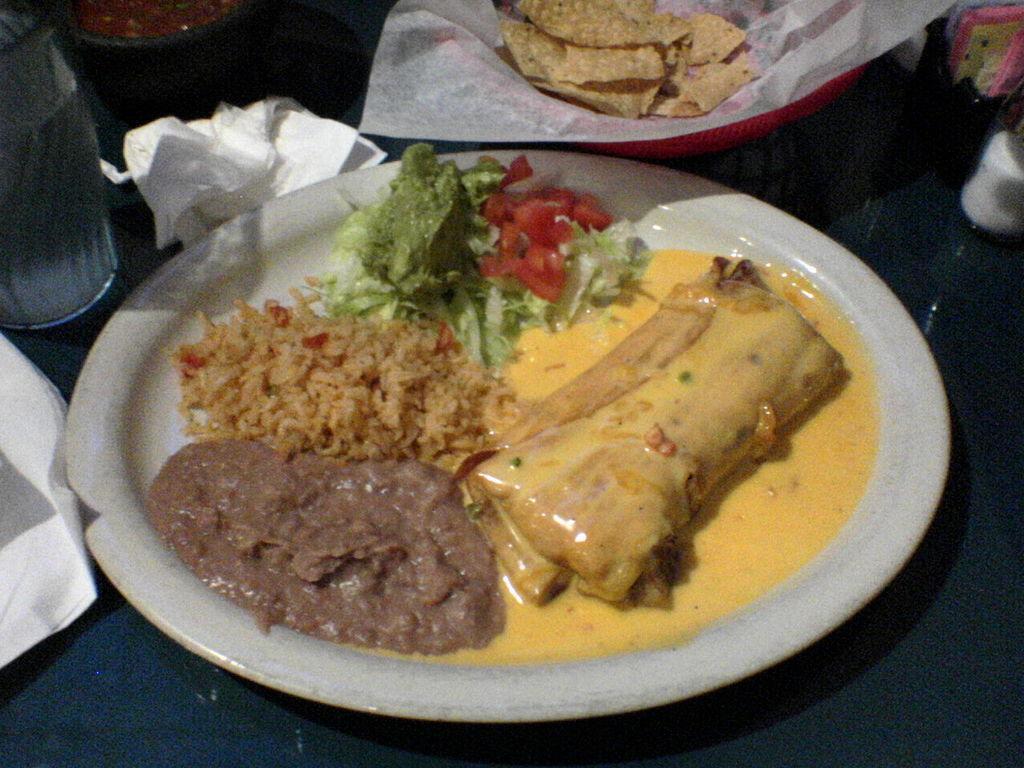Could you give a brief overview of what you see in this image? In this image there is a plate. In the plate there are different kind of dishes. Beside it there is a bowl. In the bowl there is a tissue paper in which there are chips. On the left side there is a glass bottle, beside the tissue paper. 